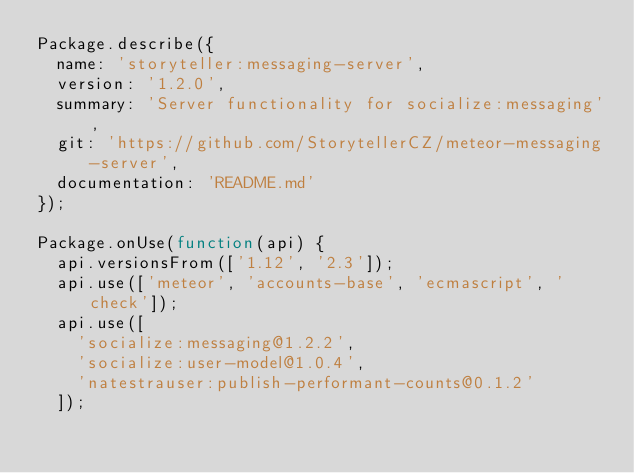Convert code to text. <code><loc_0><loc_0><loc_500><loc_500><_JavaScript_>Package.describe({
  name: 'storyteller:messaging-server',
  version: '1.2.0',
  summary: 'Server functionality for socialize:messaging',
  git: 'https://github.com/StorytellerCZ/meteor-messaging-server',
  documentation: 'README.md'
});

Package.onUse(function(api) {
  api.versionsFrom(['1.12', '2.3']);
  api.use(['meteor', 'accounts-base', 'ecmascript', 'check']);
  api.use([
    'socialize:messaging@1.2.2',
    'socialize:user-model@1.0.4',
    'natestrauser:publish-performant-counts@0.1.2'
  ]);
</code> 